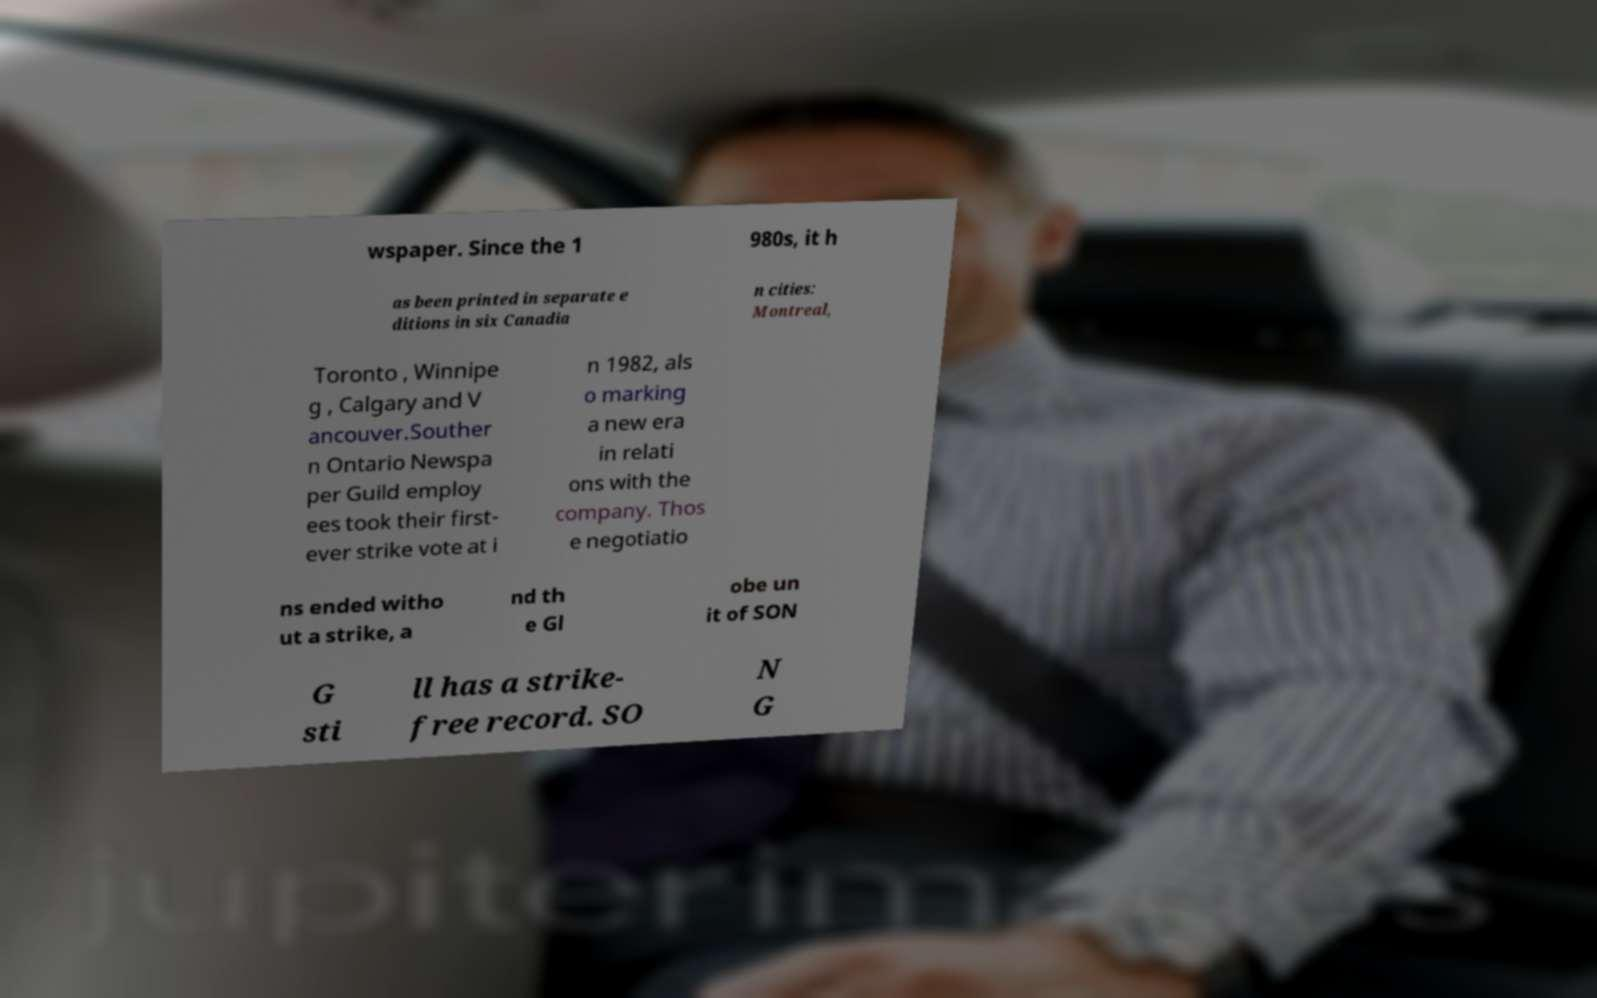Could you extract and type out the text from this image? wspaper. Since the 1 980s, it h as been printed in separate e ditions in six Canadia n cities: Montreal, Toronto , Winnipe g , Calgary and V ancouver.Souther n Ontario Newspa per Guild employ ees took their first- ever strike vote at i n 1982, als o marking a new era in relati ons with the company. Thos e negotiatio ns ended witho ut a strike, a nd th e Gl obe un it of SON G sti ll has a strike- free record. SO N G 